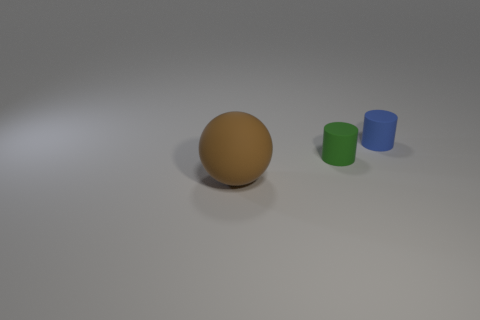There is a thing to the left of the green object; does it have the same size as the tiny green object?
Ensure brevity in your answer.  No. There is a object that is both on the left side of the small blue cylinder and on the right side of the large thing; what is its shape?
Provide a short and direct response. Cylinder. Are there more tiny green rubber objects that are left of the brown rubber object than brown balls?
Your answer should be very brief. No. There is a blue cylinder that is the same material as the ball; what is its size?
Provide a short and direct response. Small. How many cylinders have the same color as the big object?
Give a very brief answer. 0. Is the color of the matte cylinder that is left of the blue rubber cylinder the same as the matte sphere?
Offer a very short reply. No. Are there an equal number of small green rubber cylinders that are on the right side of the blue matte cylinder and blue objects that are on the left side of the large brown ball?
Provide a succinct answer. Yes. Is there anything else that is the same material as the green cylinder?
Make the answer very short. Yes. There is a tiny rubber cylinder to the left of the blue matte object; what is its color?
Offer a very short reply. Green. Are there an equal number of blue cylinders in front of the matte ball and big matte balls?
Make the answer very short. No. 